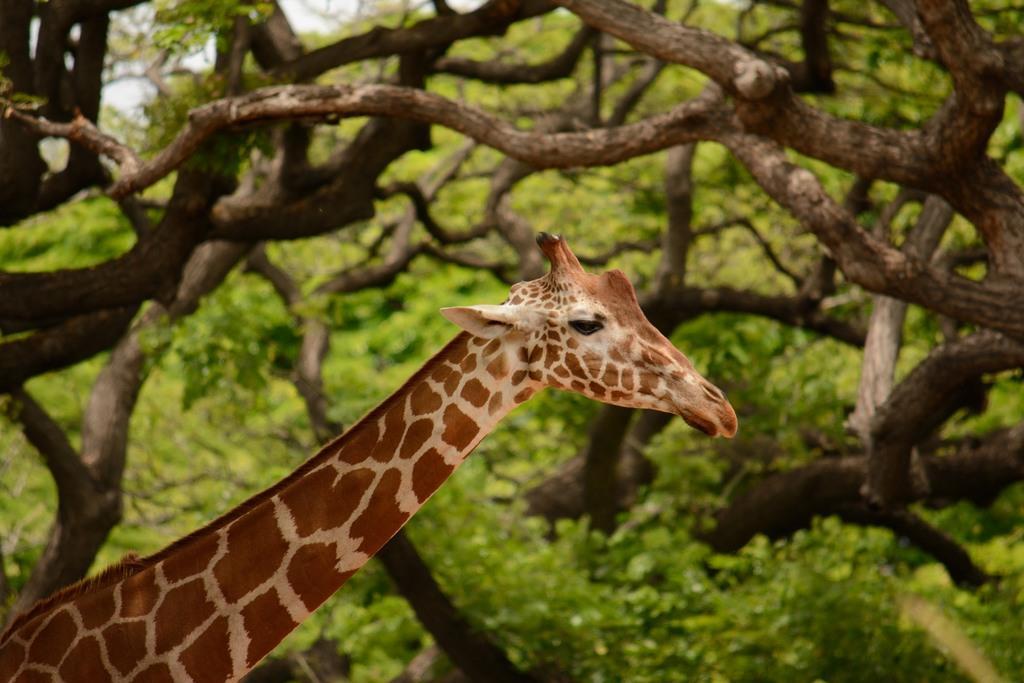Could you give a brief overview of what you see in this image? In this picture I can see the giraffe. I can see the branches of the tree. 